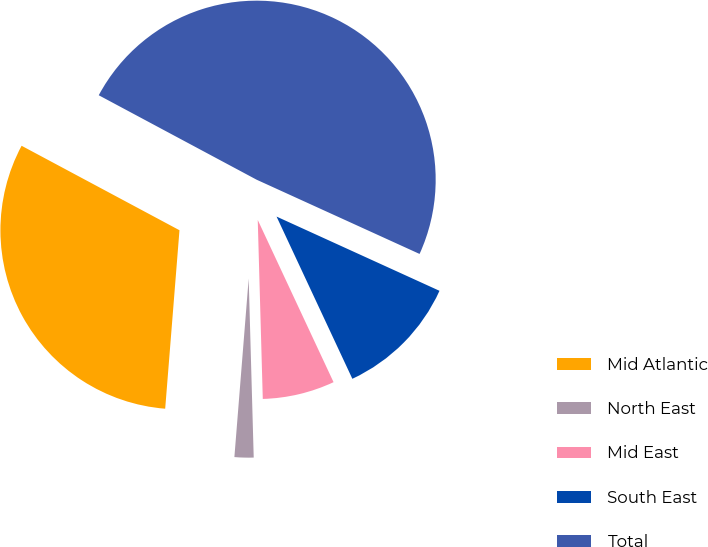Convert chart. <chart><loc_0><loc_0><loc_500><loc_500><pie_chart><fcel>Mid Atlantic<fcel>North East<fcel>Mid East<fcel>South East<fcel>Total<nl><fcel>31.55%<fcel>1.72%<fcel>6.51%<fcel>11.24%<fcel>48.99%<nl></chart> 